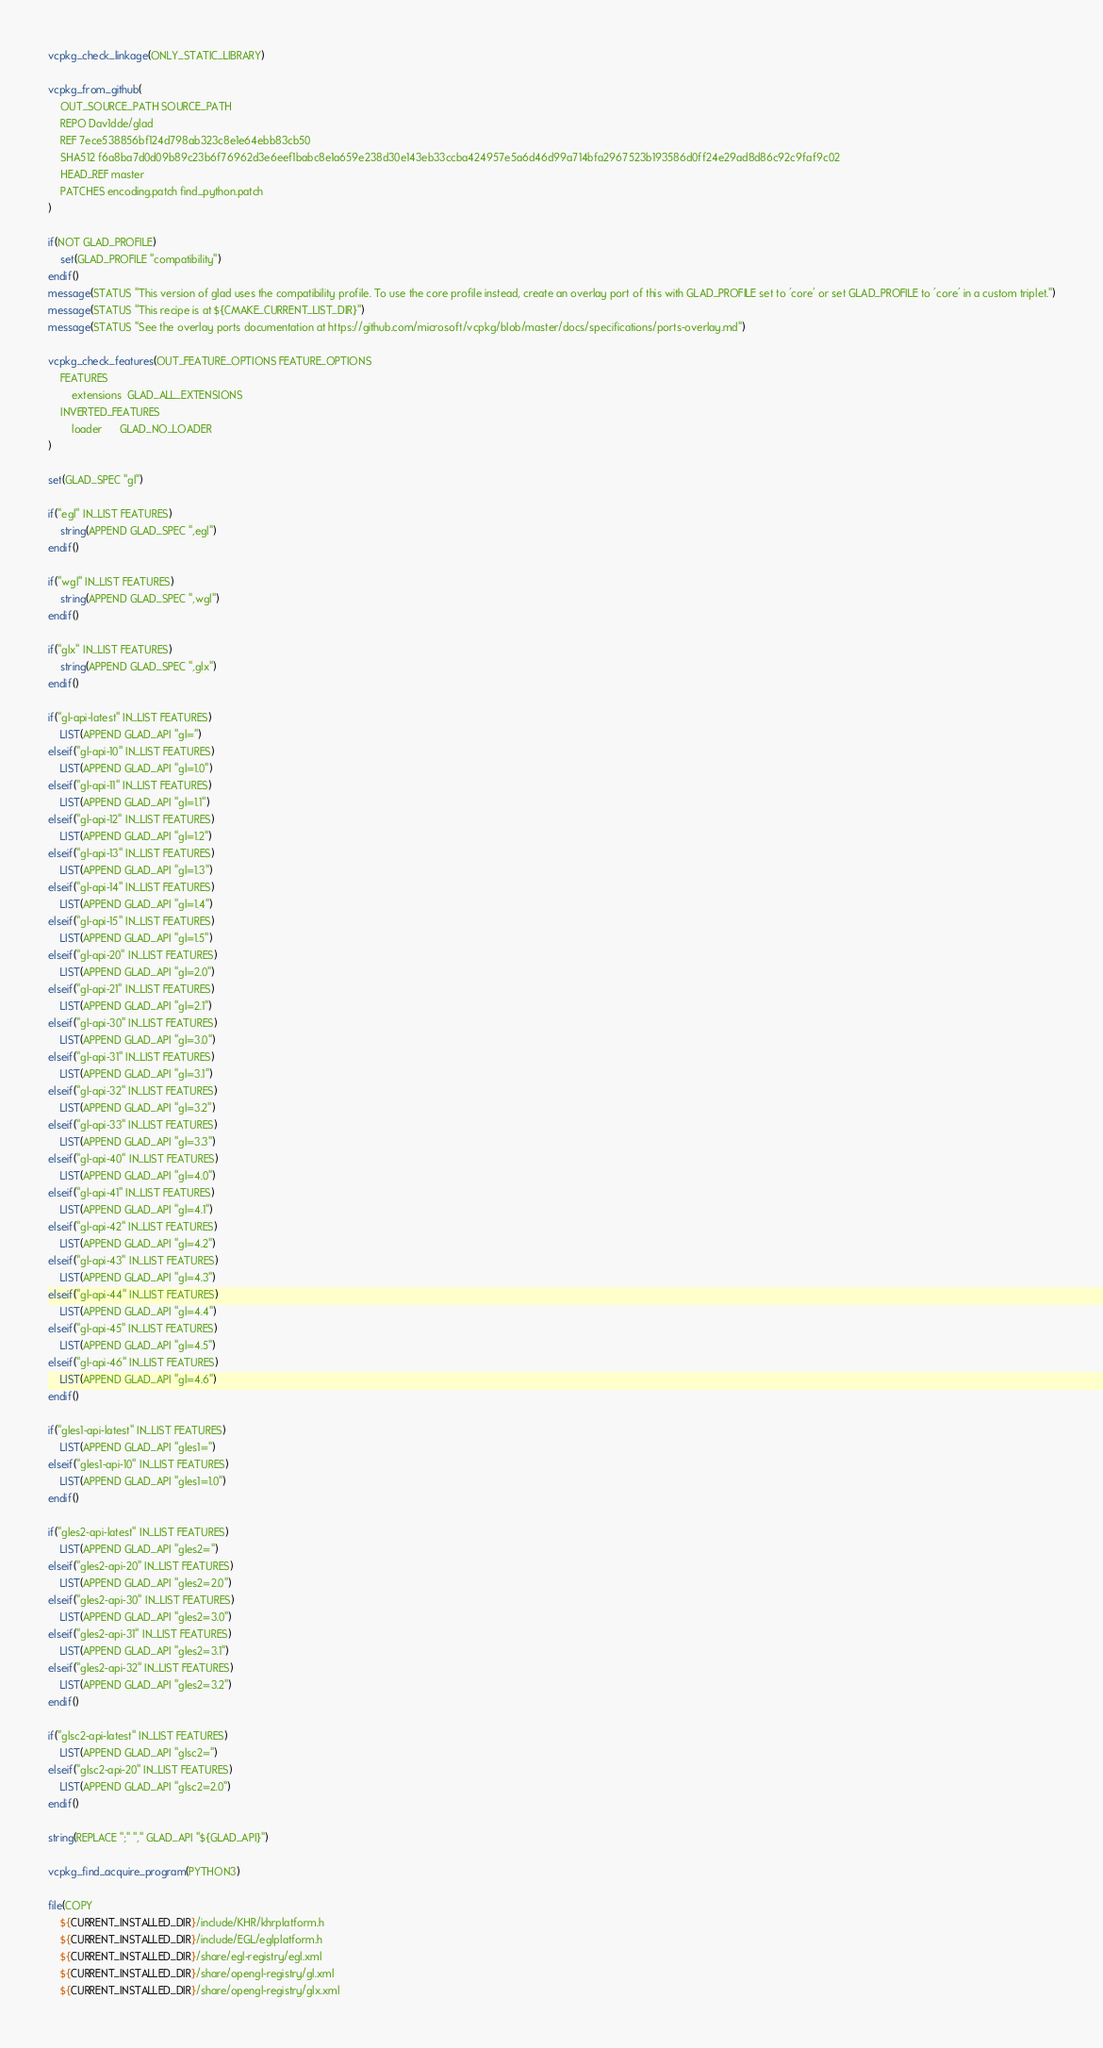Convert code to text. <code><loc_0><loc_0><loc_500><loc_500><_CMake_>vcpkg_check_linkage(ONLY_STATIC_LIBRARY)

vcpkg_from_github(
    OUT_SOURCE_PATH SOURCE_PATH
    REPO Dav1dde/glad
    REF 7ece538856bf124d798ab323c8e1e64ebb83cb50
    SHA512 f6a8ba7d0d09b89c23b6f76962d3e6eef1babc8e1a659e238d30e143eb33ccba424957e5a6d46d99a714bfa2967523b193586d0ff24e29ad8d86c92c9faf9c02
    HEAD_REF master
    PATCHES encoding.patch find_python.patch
)

if(NOT GLAD_PROFILE)
    set(GLAD_PROFILE "compatibility")
endif()
message(STATUS "This version of glad uses the compatibility profile. To use the core profile instead, create an overlay port of this with GLAD_PROFILE set to 'core' or set GLAD_PROFILE to 'core' in a custom triplet.")
message(STATUS "This recipe is at ${CMAKE_CURRENT_LIST_DIR}")
message(STATUS "See the overlay ports documentation at https://github.com/microsoft/vcpkg/blob/master/docs/specifications/ports-overlay.md")

vcpkg_check_features(OUT_FEATURE_OPTIONS FEATURE_OPTIONS
    FEATURES
        extensions  GLAD_ALL_EXTENSIONS
    INVERTED_FEATURES
        loader      GLAD_NO_LOADER
)

set(GLAD_SPEC "gl")

if("egl" IN_LIST FEATURES)
    string(APPEND GLAD_SPEC ",egl")
endif()

if("wgl" IN_LIST FEATURES)
    string(APPEND GLAD_SPEC ",wgl")
endif()

if("glx" IN_LIST FEATURES)
    string(APPEND GLAD_SPEC ",glx")
endif()

if("gl-api-latest" IN_LIST FEATURES)
    LIST(APPEND GLAD_API "gl=")
elseif("gl-api-10" IN_LIST FEATURES)
    LIST(APPEND GLAD_API "gl=1.0")
elseif("gl-api-11" IN_LIST FEATURES)
    LIST(APPEND GLAD_API "gl=1.1")
elseif("gl-api-12" IN_LIST FEATURES)
    LIST(APPEND GLAD_API "gl=1.2")
elseif("gl-api-13" IN_LIST FEATURES)
    LIST(APPEND GLAD_API "gl=1.3")
elseif("gl-api-14" IN_LIST FEATURES)
    LIST(APPEND GLAD_API "gl=1.4")
elseif("gl-api-15" IN_LIST FEATURES)
    LIST(APPEND GLAD_API "gl=1.5")
elseif("gl-api-20" IN_LIST FEATURES)
    LIST(APPEND GLAD_API "gl=2.0")
elseif("gl-api-21" IN_LIST FEATURES)
    LIST(APPEND GLAD_API "gl=2.1")
elseif("gl-api-30" IN_LIST FEATURES)
    LIST(APPEND GLAD_API "gl=3.0")
elseif("gl-api-31" IN_LIST FEATURES)
    LIST(APPEND GLAD_API "gl=3.1")
elseif("gl-api-32" IN_LIST FEATURES)
    LIST(APPEND GLAD_API "gl=3.2")
elseif("gl-api-33" IN_LIST FEATURES)
    LIST(APPEND GLAD_API "gl=3.3")
elseif("gl-api-40" IN_LIST FEATURES)
    LIST(APPEND GLAD_API "gl=4.0")
elseif("gl-api-41" IN_LIST FEATURES)
    LIST(APPEND GLAD_API "gl=4.1")
elseif("gl-api-42" IN_LIST FEATURES)
    LIST(APPEND GLAD_API "gl=4.2")
elseif("gl-api-43" IN_LIST FEATURES)
    LIST(APPEND GLAD_API "gl=4.3")
elseif("gl-api-44" IN_LIST FEATURES)
    LIST(APPEND GLAD_API "gl=4.4")
elseif("gl-api-45" IN_LIST FEATURES)
    LIST(APPEND GLAD_API "gl=4.5")
elseif("gl-api-46" IN_LIST FEATURES)
    LIST(APPEND GLAD_API "gl=4.6")
endif()

if("gles1-api-latest" IN_LIST FEATURES)
    LIST(APPEND GLAD_API "gles1=")
elseif("gles1-api-10" IN_LIST FEATURES)
    LIST(APPEND GLAD_API "gles1=1.0")
endif()

if("gles2-api-latest" IN_LIST FEATURES)
    LIST(APPEND GLAD_API "gles2=")
elseif("gles2-api-20" IN_LIST FEATURES)
    LIST(APPEND GLAD_API "gles2=2.0")
elseif("gles2-api-30" IN_LIST FEATURES)
    LIST(APPEND GLAD_API "gles2=3.0")
elseif("gles2-api-31" IN_LIST FEATURES)
    LIST(APPEND GLAD_API "gles2=3.1")
elseif("gles2-api-32" IN_LIST FEATURES)
    LIST(APPEND GLAD_API "gles2=3.2")
endif()

if("glsc2-api-latest" IN_LIST FEATURES)
    LIST(APPEND GLAD_API "glsc2=")
elseif("glsc2-api-20" IN_LIST FEATURES)
    LIST(APPEND GLAD_API "glsc2=2.0")
endif()

string(REPLACE ";" "," GLAD_API "${GLAD_API}")

vcpkg_find_acquire_program(PYTHON3)

file(COPY
    ${CURRENT_INSTALLED_DIR}/include/KHR/khrplatform.h
    ${CURRENT_INSTALLED_DIR}/include/EGL/eglplatform.h
    ${CURRENT_INSTALLED_DIR}/share/egl-registry/egl.xml
    ${CURRENT_INSTALLED_DIR}/share/opengl-registry/gl.xml
    ${CURRENT_INSTALLED_DIR}/share/opengl-registry/glx.xml</code> 